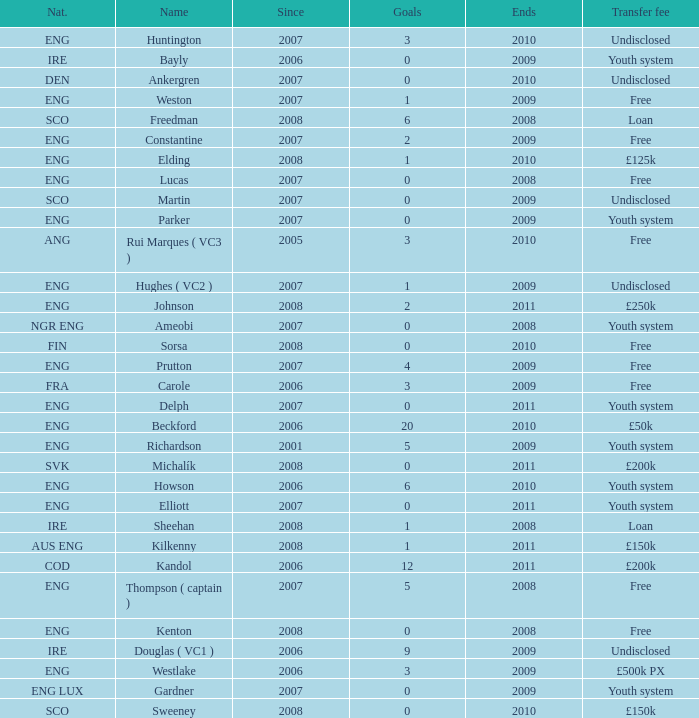Name the average ends for weston 2009.0. 